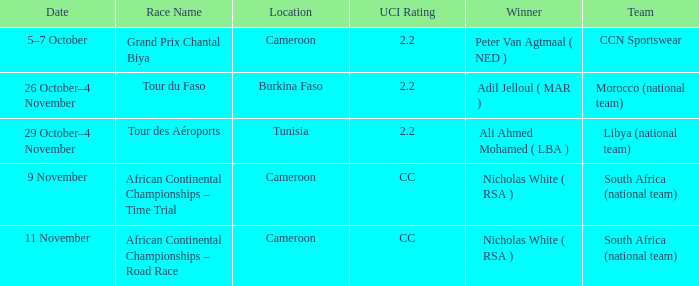What is the site of the race on 11 november? Cameroon. 